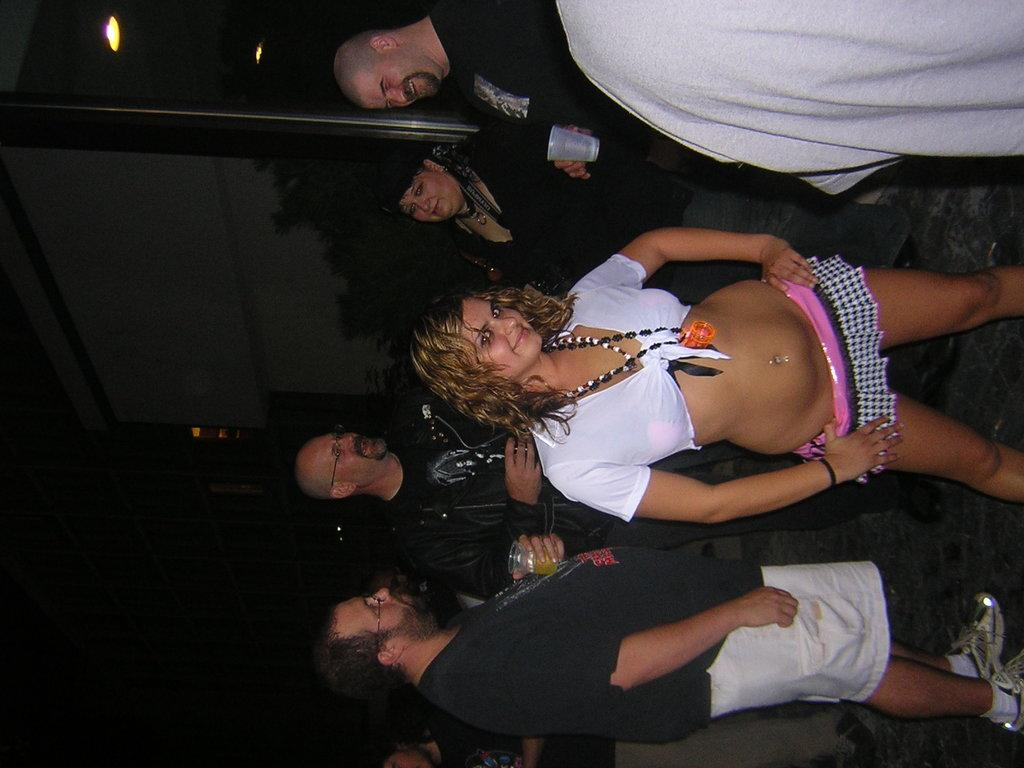What are the people in the image doing? The people in the image are standing and holding glasses. What can be seen in the background of the image? There are lights and a building visible in the background of the image. Can you tell me how many hydrants are visible in the image? There are no hydrants present in the image. What type of jellyfish can be seen swimming in the background of the image? There are no jellyfish present in the image; it features people standing with glasses and a background with lights and a building. 